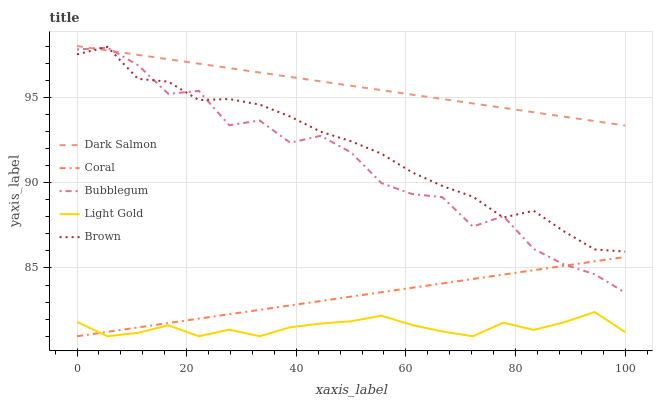Does Light Gold have the minimum area under the curve?
Answer yes or no. Yes. Does Dark Salmon have the maximum area under the curve?
Answer yes or no. Yes. Does Coral have the minimum area under the curve?
Answer yes or no. No. Does Coral have the maximum area under the curve?
Answer yes or no. No. Is Dark Salmon the smoothest?
Answer yes or no. Yes. Is Bubblegum the roughest?
Answer yes or no. Yes. Is Coral the smoothest?
Answer yes or no. No. Is Coral the roughest?
Answer yes or no. No. Does Coral have the lowest value?
Answer yes or no. Yes. Does Dark Salmon have the lowest value?
Answer yes or no. No. Does Dark Salmon have the highest value?
Answer yes or no. Yes. Does Coral have the highest value?
Answer yes or no. No. Is Light Gold less than Brown?
Answer yes or no. Yes. Is Brown greater than Light Gold?
Answer yes or no. Yes. Does Bubblegum intersect Brown?
Answer yes or no. Yes. Is Bubblegum less than Brown?
Answer yes or no. No. Is Bubblegum greater than Brown?
Answer yes or no. No. Does Light Gold intersect Brown?
Answer yes or no. No. 